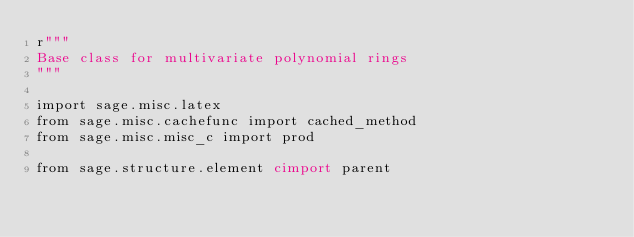<code> <loc_0><loc_0><loc_500><loc_500><_Cython_>r"""
Base class for multivariate polynomial rings
"""

import sage.misc.latex
from sage.misc.cachefunc import cached_method
from sage.misc.misc_c import prod

from sage.structure.element cimport parent</code> 